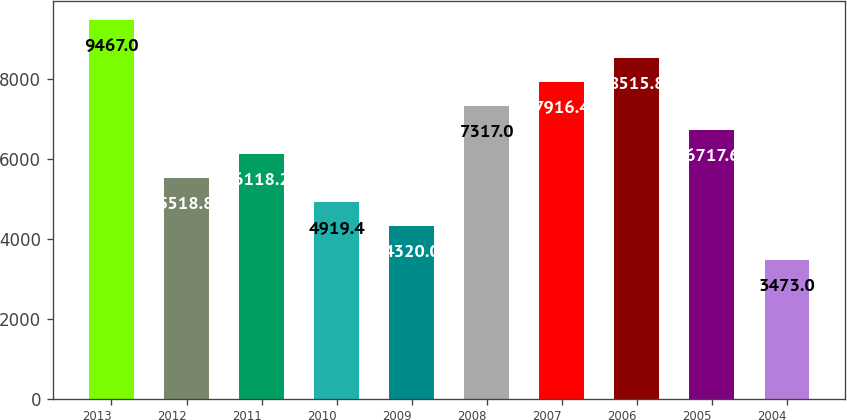<chart> <loc_0><loc_0><loc_500><loc_500><bar_chart><fcel>2013<fcel>2012<fcel>2011<fcel>2010<fcel>2009<fcel>2008<fcel>2007<fcel>2006<fcel>2005<fcel>2004<nl><fcel>9467<fcel>5518.8<fcel>6118.2<fcel>4919.4<fcel>4320<fcel>7317<fcel>7916.4<fcel>8515.8<fcel>6717.6<fcel>3473<nl></chart> 